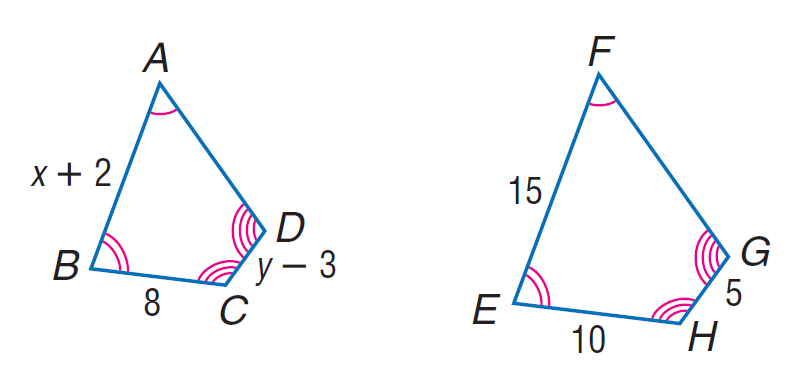Answer the mathemtical geometry problem and directly provide the correct option letter.
Question: Each pair of polygons is similar. Find y.
Choices: A: 7 B: 8 C: 10 D: 45 A 